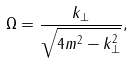Convert formula to latex. <formula><loc_0><loc_0><loc_500><loc_500>\Omega = \frac { k _ { \bot } } { \sqrt { 4 m ^ { 2 } - k _ { \bot } ^ { 2 } } } ,</formula> 